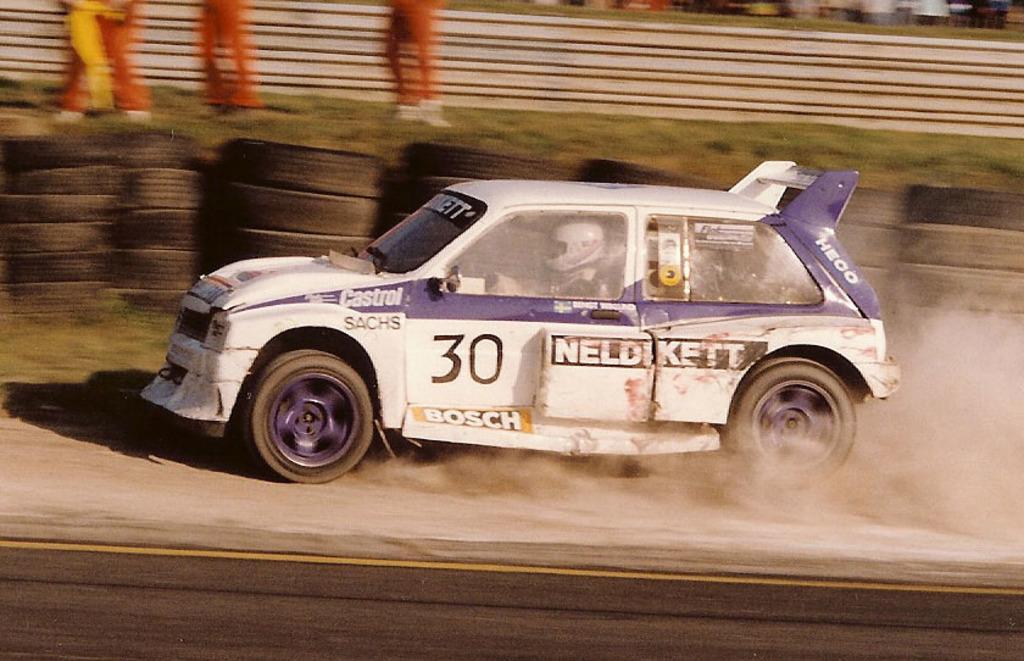Can you describe this image briefly? In this image I can see a vehicle which is in white and purple color. I can also see a person sitting inside the vehicle. Background I can see grass in green color. 